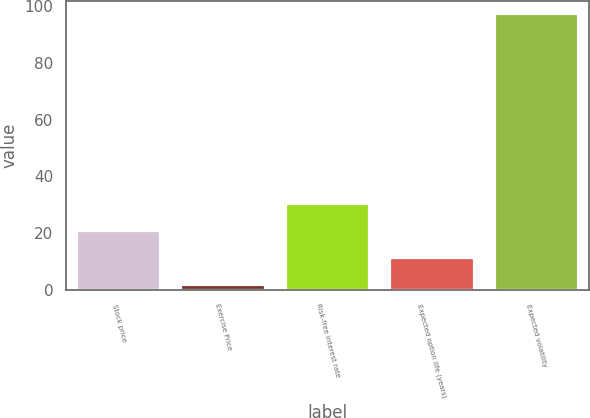<chart> <loc_0><loc_0><loc_500><loc_500><bar_chart><fcel>Stock price<fcel>Exercise Price<fcel>Risk-free interest rate<fcel>Expected option life (years)<fcel>Expected volatility<nl><fcel>20.82<fcel>1.75<fcel>30.36<fcel>11.29<fcel>97.1<nl></chart> 